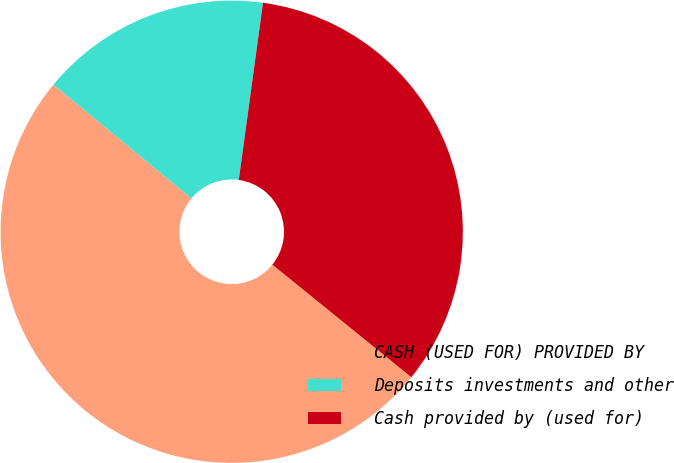<chart> <loc_0><loc_0><loc_500><loc_500><pie_chart><fcel>CASH (USED FOR) PROVIDED BY<fcel>Deposits investments and other<fcel>Cash provided by (used for)<nl><fcel>50.15%<fcel>16.18%<fcel>33.67%<nl></chart> 